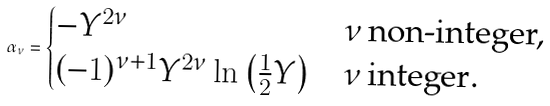Convert formula to latex. <formula><loc_0><loc_0><loc_500><loc_500>\alpha _ { \nu } = \begin{cases} - Y ^ { 2 \nu } & \nu \, \text {non-integer,} \\ ( - 1 ) ^ { \nu + 1 } Y ^ { 2 \nu } \ln \left ( \frac { 1 } { 2 } Y \right ) & \nu \, \text {integer} . \end{cases}</formula> 